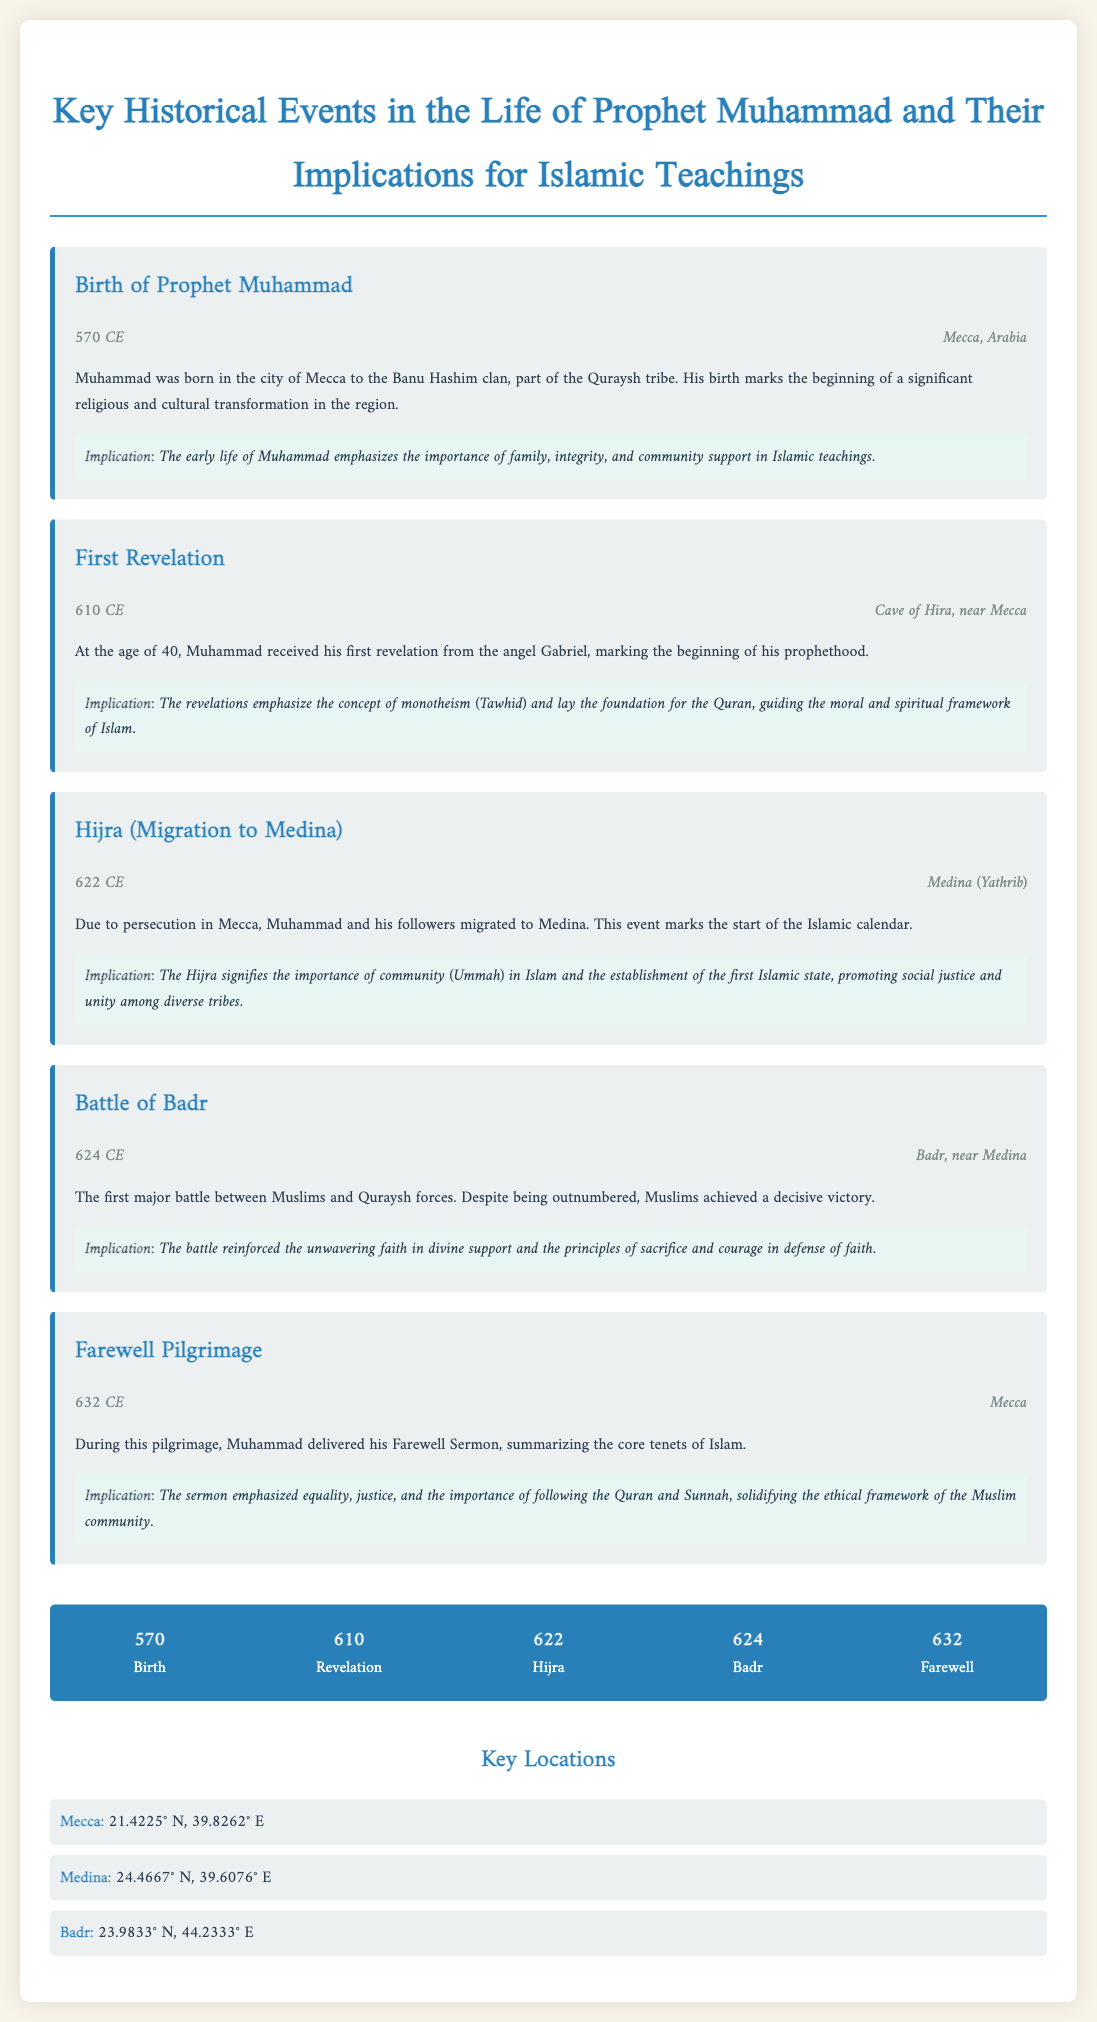What year was Prophet Muhammad born? The document states his birth year as 570 CE.
Answer: 570 CE Where did the first revelation occur? The document mentions that the first revelation took place in the Cave of Hira, near Mecca.
Answer: Cave of Hira, near Mecca What event marks the start of the Islamic calendar? The Hijra (Migration to Medina) is identified as the event that marks the beginning of the Islamic calendar in the document.
Answer: Hijra What was the outcome of the Battle of Badr? The document indicates that Muslims achieved a decisive victory despite being outnumbered.
Answer: Decisive victory What key principle is emphasized in Muhammad's Farewell Sermon? The document highlights that the Farewell Sermon emphasized equality, justice, and following the Quran and Sunnah.
Answer: Equality, justice, and following the Quran and Sunnah What does the timeline indicate occurred in 624 CE? The timeline specifies the Battle of Badr as the event that happened in 624 CE.
Answer: Battle of Badr Which city is mentioned as the birthplace of Prophet Muhammad? The document identifies Mecca as the birthplace of Prophet Muhammad.
Answer: Mecca What is one implication of the Hijra according to the document? The document states that the Hijra signifies the importance of community (Ummah) in Islam.
Answer: Community (Ummah) What is the latitude coordinate of Medina? The document provides the latitude coordinate of Medina as 24.4667° N.
Answer: 24.4667° N 